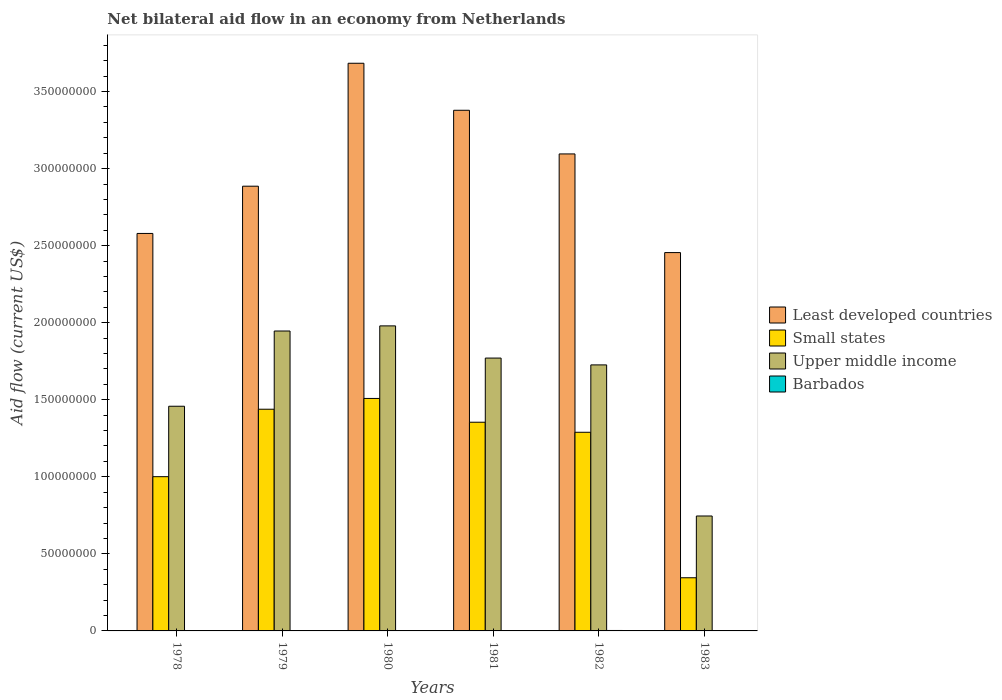How many different coloured bars are there?
Give a very brief answer. 4. How many groups of bars are there?
Offer a terse response. 6. How many bars are there on the 4th tick from the left?
Ensure brevity in your answer.  4. In how many cases, is the number of bars for a given year not equal to the number of legend labels?
Your answer should be very brief. 0. What is the net bilateral aid flow in Least developed countries in 1983?
Make the answer very short. 2.46e+08. Across all years, what is the maximum net bilateral aid flow in Upper middle income?
Offer a terse response. 1.98e+08. In which year was the net bilateral aid flow in Small states maximum?
Provide a succinct answer. 1980. In which year was the net bilateral aid flow in Small states minimum?
Your answer should be very brief. 1983. What is the total net bilateral aid flow in Least developed countries in the graph?
Provide a short and direct response. 1.81e+09. What is the difference between the net bilateral aid flow in Barbados in 1979 and that in 1980?
Provide a short and direct response. -7.00e+04. What is the difference between the net bilateral aid flow in Small states in 1982 and the net bilateral aid flow in Barbados in 1983?
Make the answer very short. 1.29e+08. What is the average net bilateral aid flow in Small states per year?
Make the answer very short. 1.16e+08. In the year 1981, what is the difference between the net bilateral aid flow in Small states and net bilateral aid flow in Least developed countries?
Give a very brief answer. -2.02e+08. What is the ratio of the net bilateral aid flow in Upper middle income in 1980 to that in 1983?
Provide a short and direct response. 2.65. Is the net bilateral aid flow in Least developed countries in 1980 less than that in 1981?
Offer a terse response. No. What is the difference between the highest and the second highest net bilateral aid flow in Upper middle income?
Your answer should be compact. 3.32e+06. What is the difference between the highest and the lowest net bilateral aid flow in Upper middle income?
Offer a terse response. 1.23e+08. In how many years, is the net bilateral aid flow in Upper middle income greater than the average net bilateral aid flow in Upper middle income taken over all years?
Offer a very short reply. 4. Is the sum of the net bilateral aid flow in Least developed countries in 1980 and 1983 greater than the maximum net bilateral aid flow in Barbados across all years?
Provide a short and direct response. Yes. What does the 2nd bar from the left in 1979 represents?
Provide a succinct answer. Small states. What does the 3rd bar from the right in 1978 represents?
Keep it short and to the point. Small states. Is it the case that in every year, the sum of the net bilateral aid flow in Least developed countries and net bilateral aid flow in Upper middle income is greater than the net bilateral aid flow in Barbados?
Make the answer very short. Yes. How many years are there in the graph?
Provide a short and direct response. 6. What is the difference between two consecutive major ticks on the Y-axis?
Your answer should be very brief. 5.00e+07. Are the values on the major ticks of Y-axis written in scientific E-notation?
Your answer should be compact. No. Does the graph contain any zero values?
Ensure brevity in your answer.  No. Where does the legend appear in the graph?
Offer a terse response. Center right. How many legend labels are there?
Ensure brevity in your answer.  4. What is the title of the graph?
Provide a short and direct response. Net bilateral aid flow in an economy from Netherlands. What is the label or title of the X-axis?
Your answer should be very brief. Years. What is the Aid flow (current US$) in Least developed countries in 1978?
Provide a short and direct response. 2.58e+08. What is the Aid flow (current US$) in Small states in 1978?
Provide a short and direct response. 1.00e+08. What is the Aid flow (current US$) of Upper middle income in 1978?
Make the answer very short. 1.46e+08. What is the Aid flow (current US$) in Barbados in 1978?
Provide a short and direct response. 7.00e+04. What is the Aid flow (current US$) in Least developed countries in 1979?
Your answer should be compact. 2.89e+08. What is the Aid flow (current US$) in Small states in 1979?
Give a very brief answer. 1.44e+08. What is the Aid flow (current US$) of Upper middle income in 1979?
Give a very brief answer. 1.95e+08. What is the Aid flow (current US$) in Barbados in 1979?
Keep it short and to the point. 4.00e+04. What is the Aid flow (current US$) in Least developed countries in 1980?
Make the answer very short. 3.68e+08. What is the Aid flow (current US$) in Small states in 1980?
Ensure brevity in your answer.  1.51e+08. What is the Aid flow (current US$) in Upper middle income in 1980?
Provide a succinct answer. 1.98e+08. What is the Aid flow (current US$) in Barbados in 1980?
Give a very brief answer. 1.10e+05. What is the Aid flow (current US$) in Least developed countries in 1981?
Offer a very short reply. 3.38e+08. What is the Aid flow (current US$) in Small states in 1981?
Your answer should be compact. 1.35e+08. What is the Aid flow (current US$) of Upper middle income in 1981?
Offer a very short reply. 1.77e+08. What is the Aid flow (current US$) in Barbados in 1981?
Provide a succinct answer. 2.00e+04. What is the Aid flow (current US$) in Least developed countries in 1982?
Your response must be concise. 3.10e+08. What is the Aid flow (current US$) in Small states in 1982?
Ensure brevity in your answer.  1.29e+08. What is the Aid flow (current US$) of Upper middle income in 1982?
Offer a very short reply. 1.73e+08. What is the Aid flow (current US$) of Barbados in 1982?
Your response must be concise. 2.90e+05. What is the Aid flow (current US$) in Least developed countries in 1983?
Give a very brief answer. 2.46e+08. What is the Aid flow (current US$) in Small states in 1983?
Give a very brief answer. 3.45e+07. What is the Aid flow (current US$) of Upper middle income in 1983?
Provide a succinct answer. 7.46e+07. What is the Aid flow (current US$) in Barbados in 1983?
Your response must be concise. 1.60e+05. Across all years, what is the maximum Aid flow (current US$) of Least developed countries?
Offer a terse response. 3.68e+08. Across all years, what is the maximum Aid flow (current US$) of Small states?
Make the answer very short. 1.51e+08. Across all years, what is the maximum Aid flow (current US$) of Upper middle income?
Ensure brevity in your answer.  1.98e+08. Across all years, what is the maximum Aid flow (current US$) in Barbados?
Your response must be concise. 2.90e+05. Across all years, what is the minimum Aid flow (current US$) of Least developed countries?
Your response must be concise. 2.46e+08. Across all years, what is the minimum Aid flow (current US$) of Small states?
Offer a very short reply. 3.45e+07. Across all years, what is the minimum Aid flow (current US$) in Upper middle income?
Your answer should be very brief. 7.46e+07. What is the total Aid flow (current US$) in Least developed countries in the graph?
Your response must be concise. 1.81e+09. What is the total Aid flow (current US$) of Small states in the graph?
Your response must be concise. 6.94e+08. What is the total Aid flow (current US$) in Upper middle income in the graph?
Ensure brevity in your answer.  9.63e+08. What is the total Aid flow (current US$) in Barbados in the graph?
Give a very brief answer. 6.90e+05. What is the difference between the Aid flow (current US$) of Least developed countries in 1978 and that in 1979?
Offer a very short reply. -3.07e+07. What is the difference between the Aid flow (current US$) in Small states in 1978 and that in 1979?
Keep it short and to the point. -4.38e+07. What is the difference between the Aid flow (current US$) in Upper middle income in 1978 and that in 1979?
Make the answer very short. -4.88e+07. What is the difference between the Aid flow (current US$) of Barbados in 1978 and that in 1979?
Give a very brief answer. 3.00e+04. What is the difference between the Aid flow (current US$) of Least developed countries in 1978 and that in 1980?
Offer a terse response. -1.10e+08. What is the difference between the Aid flow (current US$) in Small states in 1978 and that in 1980?
Your answer should be compact. -5.08e+07. What is the difference between the Aid flow (current US$) in Upper middle income in 1978 and that in 1980?
Your answer should be compact. -5.21e+07. What is the difference between the Aid flow (current US$) of Least developed countries in 1978 and that in 1981?
Your answer should be compact. -7.99e+07. What is the difference between the Aid flow (current US$) in Small states in 1978 and that in 1981?
Provide a succinct answer. -3.53e+07. What is the difference between the Aid flow (current US$) of Upper middle income in 1978 and that in 1981?
Provide a succinct answer. -3.12e+07. What is the difference between the Aid flow (current US$) of Barbados in 1978 and that in 1981?
Provide a short and direct response. 5.00e+04. What is the difference between the Aid flow (current US$) in Least developed countries in 1978 and that in 1982?
Offer a very short reply. -5.16e+07. What is the difference between the Aid flow (current US$) of Small states in 1978 and that in 1982?
Your answer should be compact. -2.88e+07. What is the difference between the Aid flow (current US$) in Upper middle income in 1978 and that in 1982?
Provide a succinct answer. -2.68e+07. What is the difference between the Aid flow (current US$) in Barbados in 1978 and that in 1982?
Your answer should be very brief. -2.20e+05. What is the difference between the Aid flow (current US$) in Least developed countries in 1978 and that in 1983?
Give a very brief answer. 1.24e+07. What is the difference between the Aid flow (current US$) of Small states in 1978 and that in 1983?
Provide a succinct answer. 6.56e+07. What is the difference between the Aid flow (current US$) of Upper middle income in 1978 and that in 1983?
Make the answer very short. 7.12e+07. What is the difference between the Aid flow (current US$) in Barbados in 1978 and that in 1983?
Keep it short and to the point. -9.00e+04. What is the difference between the Aid flow (current US$) in Least developed countries in 1979 and that in 1980?
Provide a short and direct response. -7.98e+07. What is the difference between the Aid flow (current US$) in Small states in 1979 and that in 1980?
Your answer should be compact. -6.99e+06. What is the difference between the Aid flow (current US$) in Upper middle income in 1979 and that in 1980?
Give a very brief answer. -3.32e+06. What is the difference between the Aid flow (current US$) of Least developed countries in 1979 and that in 1981?
Your answer should be very brief. -4.93e+07. What is the difference between the Aid flow (current US$) of Small states in 1979 and that in 1981?
Provide a succinct answer. 8.44e+06. What is the difference between the Aid flow (current US$) of Upper middle income in 1979 and that in 1981?
Provide a succinct answer. 1.76e+07. What is the difference between the Aid flow (current US$) in Least developed countries in 1979 and that in 1982?
Make the answer very short. -2.09e+07. What is the difference between the Aid flow (current US$) of Small states in 1979 and that in 1982?
Your answer should be very brief. 1.50e+07. What is the difference between the Aid flow (current US$) of Upper middle income in 1979 and that in 1982?
Your response must be concise. 2.20e+07. What is the difference between the Aid flow (current US$) in Barbados in 1979 and that in 1982?
Your answer should be very brief. -2.50e+05. What is the difference between the Aid flow (current US$) of Least developed countries in 1979 and that in 1983?
Your answer should be very brief. 4.31e+07. What is the difference between the Aid flow (current US$) in Small states in 1979 and that in 1983?
Ensure brevity in your answer.  1.09e+08. What is the difference between the Aid flow (current US$) in Upper middle income in 1979 and that in 1983?
Your answer should be compact. 1.20e+08. What is the difference between the Aid flow (current US$) of Barbados in 1979 and that in 1983?
Provide a short and direct response. -1.20e+05. What is the difference between the Aid flow (current US$) in Least developed countries in 1980 and that in 1981?
Your response must be concise. 3.05e+07. What is the difference between the Aid flow (current US$) in Small states in 1980 and that in 1981?
Give a very brief answer. 1.54e+07. What is the difference between the Aid flow (current US$) of Upper middle income in 1980 and that in 1981?
Your answer should be very brief. 2.09e+07. What is the difference between the Aid flow (current US$) of Least developed countries in 1980 and that in 1982?
Your response must be concise. 5.88e+07. What is the difference between the Aid flow (current US$) of Small states in 1980 and that in 1982?
Your response must be concise. 2.20e+07. What is the difference between the Aid flow (current US$) in Upper middle income in 1980 and that in 1982?
Ensure brevity in your answer.  2.53e+07. What is the difference between the Aid flow (current US$) in Barbados in 1980 and that in 1982?
Offer a terse response. -1.80e+05. What is the difference between the Aid flow (current US$) in Least developed countries in 1980 and that in 1983?
Provide a succinct answer. 1.23e+08. What is the difference between the Aid flow (current US$) in Small states in 1980 and that in 1983?
Ensure brevity in your answer.  1.16e+08. What is the difference between the Aid flow (current US$) of Upper middle income in 1980 and that in 1983?
Provide a short and direct response. 1.23e+08. What is the difference between the Aid flow (current US$) in Least developed countries in 1981 and that in 1982?
Your response must be concise. 2.83e+07. What is the difference between the Aid flow (current US$) of Small states in 1981 and that in 1982?
Offer a terse response. 6.52e+06. What is the difference between the Aid flow (current US$) of Upper middle income in 1981 and that in 1982?
Make the answer very short. 4.43e+06. What is the difference between the Aid flow (current US$) of Barbados in 1981 and that in 1982?
Give a very brief answer. -2.70e+05. What is the difference between the Aid flow (current US$) of Least developed countries in 1981 and that in 1983?
Provide a succinct answer. 9.24e+07. What is the difference between the Aid flow (current US$) in Small states in 1981 and that in 1983?
Provide a short and direct response. 1.01e+08. What is the difference between the Aid flow (current US$) of Upper middle income in 1981 and that in 1983?
Ensure brevity in your answer.  1.02e+08. What is the difference between the Aid flow (current US$) of Barbados in 1981 and that in 1983?
Ensure brevity in your answer.  -1.40e+05. What is the difference between the Aid flow (current US$) of Least developed countries in 1982 and that in 1983?
Give a very brief answer. 6.40e+07. What is the difference between the Aid flow (current US$) in Small states in 1982 and that in 1983?
Your answer should be compact. 9.44e+07. What is the difference between the Aid flow (current US$) in Upper middle income in 1982 and that in 1983?
Give a very brief answer. 9.80e+07. What is the difference between the Aid flow (current US$) of Least developed countries in 1978 and the Aid flow (current US$) of Small states in 1979?
Ensure brevity in your answer.  1.14e+08. What is the difference between the Aid flow (current US$) in Least developed countries in 1978 and the Aid flow (current US$) in Upper middle income in 1979?
Make the answer very short. 6.33e+07. What is the difference between the Aid flow (current US$) of Least developed countries in 1978 and the Aid flow (current US$) of Barbados in 1979?
Provide a succinct answer. 2.58e+08. What is the difference between the Aid flow (current US$) of Small states in 1978 and the Aid flow (current US$) of Upper middle income in 1979?
Offer a terse response. -9.45e+07. What is the difference between the Aid flow (current US$) of Small states in 1978 and the Aid flow (current US$) of Barbados in 1979?
Provide a succinct answer. 1.00e+08. What is the difference between the Aid flow (current US$) of Upper middle income in 1978 and the Aid flow (current US$) of Barbados in 1979?
Keep it short and to the point. 1.46e+08. What is the difference between the Aid flow (current US$) of Least developed countries in 1978 and the Aid flow (current US$) of Small states in 1980?
Your response must be concise. 1.07e+08. What is the difference between the Aid flow (current US$) of Least developed countries in 1978 and the Aid flow (current US$) of Upper middle income in 1980?
Provide a short and direct response. 6.00e+07. What is the difference between the Aid flow (current US$) in Least developed countries in 1978 and the Aid flow (current US$) in Barbados in 1980?
Your response must be concise. 2.58e+08. What is the difference between the Aid flow (current US$) of Small states in 1978 and the Aid flow (current US$) of Upper middle income in 1980?
Offer a terse response. -9.78e+07. What is the difference between the Aid flow (current US$) of Small states in 1978 and the Aid flow (current US$) of Barbados in 1980?
Keep it short and to the point. 1.00e+08. What is the difference between the Aid flow (current US$) in Upper middle income in 1978 and the Aid flow (current US$) in Barbados in 1980?
Your response must be concise. 1.46e+08. What is the difference between the Aid flow (current US$) of Least developed countries in 1978 and the Aid flow (current US$) of Small states in 1981?
Provide a short and direct response. 1.22e+08. What is the difference between the Aid flow (current US$) in Least developed countries in 1978 and the Aid flow (current US$) in Upper middle income in 1981?
Your response must be concise. 8.09e+07. What is the difference between the Aid flow (current US$) of Least developed countries in 1978 and the Aid flow (current US$) of Barbados in 1981?
Your response must be concise. 2.58e+08. What is the difference between the Aid flow (current US$) of Small states in 1978 and the Aid flow (current US$) of Upper middle income in 1981?
Provide a short and direct response. -7.70e+07. What is the difference between the Aid flow (current US$) in Small states in 1978 and the Aid flow (current US$) in Barbados in 1981?
Your response must be concise. 1.00e+08. What is the difference between the Aid flow (current US$) of Upper middle income in 1978 and the Aid flow (current US$) of Barbados in 1981?
Your answer should be very brief. 1.46e+08. What is the difference between the Aid flow (current US$) of Least developed countries in 1978 and the Aid flow (current US$) of Small states in 1982?
Give a very brief answer. 1.29e+08. What is the difference between the Aid flow (current US$) in Least developed countries in 1978 and the Aid flow (current US$) in Upper middle income in 1982?
Keep it short and to the point. 8.53e+07. What is the difference between the Aid flow (current US$) in Least developed countries in 1978 and the Aid flow (current US$) in Barbados in 1982?
Keep it short and to the point. 2.58e+08. What is the difference between the Aid flow (current US$) in Small states in 1978 and the Aid flow (current US$) in Upper middle income in 1982?
Give a very brief answer. -7.25e+07. What is the difference between the Aid flow (current US$) of Small states in 1978 and the Aid flow (current US$) of Barbados in 1982?
Ensure brevity in your answer.  9.98e+07. What is the difference between the Aid flow (current US$) in Upper middle income in 1978 and the Aid flow (current US$) in Barbados in 1982?
Make the answer very short. 1.46e+08. What is the difference between the Aid flow (current US$) in Least developed countries in 1978 and the Aid flow (current US$) in Small states in 1983?
Give a very brief answer. 2.23e+08. What is the difference between the Aid flow (current US$) in Least developed countries in 1978 and the Aid flow (current US$) in Upper middle income in 1983?
Provide a succinct answer. 1.83e+08. What is the difference between the Aid flow (current US$) in Least developed countries in 1978 and the Aid flow (current US$) in Barbados in 1983?
Provide a succinct answer. 2.58e+08. What is the difference between the Aid flow (current US$) of Small states in 1978 and the Aid flow (current US$) of Upper middle income in 1983?
Your answer should be compact. 2.55e+07. What is the difference between the Aid flow (current US$) in Small states in 1978 and the Aid flow (current US$) in Barbados in 1983?
Offer a terse response. 9.99e+07. What is the difference between the Aid flow (current US$) of Upper middle income in 1978 and the Aid flow (current US$) of Barbados in 1983?
Your response must be concise. 1.46e+08. What is the difference between the Aid flow (current US$) in Least developed countries in 1979 and the Aid flow (current US$) in Small states in 1980?
Your answer should be compact. 1.38e+08. What is the difference between the Aid flow (current US$) in Least developed countries in 1979 and the Aid flow (current US$) in Upper middle income in 1980?
Ensure brevity in your answer.  9.06e+07. What is the difference between the Aid flow (current US$) of Least developed countries in 1979 and the Aid flow (current US$) of Barbados in 1980?
Make the answer very short. 2.88e+08. What is the difference between the Aid flow (current US$) in Small states in 1979 and the Aid flow (current US$) in Upper middle income in 1980?
Give a very brief answer. -5.41e+07. What is the difference between the Aid flow (current US$) of Small states in 1979 and the Aid flow (current US$) of Barbados in 1980?
Your answer should be very brief. 1.44e+08. What is the difference between the Aid flow (current US$) of Upper middle income in 1979 and the Aid flow (current US$) of Barbados in 1980?
Your answer should be very brief. 1.95e+08. What is the difference between the Aid flow (current US$) of Least developed countries in 1979 and the Aid flow (current US$) of Small states in 1981?
Your answer should be very brief. 1.53e+08. What is the difference between the Aid flow (current US$) in Least developed countries in 1979 and the Aid flow (current US$) in Upper middle income in 1981?
Ensure brevity in your answer.  1.12e+08. What is the difference between the Aid flow (current US$) in Least developed countries in 1979 and the Aid flow (current US$) in Barbados in 1981?
Make the answer very short. 2.89e+08. What is the difference between the Aid flow (current US$) of Small states in 1979 and the Aid flow (current US$) of Upper middle income in 1981?
Make the answer very short. -3.32e+07. What is the difference between the Aid flow (current US$) of Small states in 1979 and the Aid flow (current US$) of Barbados in 1981?
Provide a succinct answer. 1.44e+08. What is the difference between the Aid flow (current US$) in Upper middle income in 1979 and the Aid flow (current US$) in Barbados in 1981?
Offer a very short reply. 1.95e+08. What is the difference between the Aid flow (current US$) in Least developed countries in 1979 and the Aid flow (current US$) in Small states in 1982?
Give a very brief answer. 1.60e+08. What is the difference between the Aid flow (current US$) of Least developed countries in 1979 and the Aid flow (current US$) of Upper middle income in 1982?
Keep it short and to the point. 1.16e+08. What is the difference between the Aid flow (current US$) in Least developed countries in 1979 and the Aid flow (current US$) in Barbados in 1982?
Your response must be concise. 2.88e+08. What is the difference between the Aid flow (current US$) in Small states in 1979 and the Aid flow (current US$) in Upper middle income in 1982?
Provide a succinct answer. -2.88e+07. What is the difference between the Aid flow (current US$) in Small states in 1979 and the Aid flow (current US$) in Barbados in 1982?
Make the answer very short. 1.44e+08. What is the difference between the Aid flow (current US$) in Upper middle income in 1979 and the Aid flow (current US$) in Barbados in 1982?
Provide a succinct answer. 1.94e+08. What is the difference between the Aid flow (current US$) in Least developed countries in 1979 and the Aid flow (current US$) in Small states in 1983?
Give a very brief answer. 2.54e+08. What is the difference between the Aid flow (current US$) in Least developed countries in 1979 and the Aid flow (current US$) in Upper middle income in 1983?
Offer a terse response. 2.14e+08. What is the difference between the Aid flow (current US$) in Least developed countries in 1979 and the Aid flow (current US$) in Barbados in 1983?
Provide a short and direct response. 2.88e+08. What is the difference between the Aid flow (current US$) in Small states in 1979 and the Aid flow (current US$) in Upper middle income in 1983?
Give a very brief answer. 6.93e+07. What is the difference between the Aid flow (current US$) of Small states in 1979 and the Aid flow (current US$) of Barbados in 1983?
Provide a short and direct response. 1.44e+08. What is the difference between the Aid flow (current US$) of Upper middle income in 1979 and the Aid flow (current US$) of Barbados in 1983?
Give a very brief answer. 1.94e+08. What is the difference between the Aid flow (current US$) in Least developed countries in 1980 and the Aid flow (current US$) in Small states in 1981?
Your answer should be compact. 2.33e+08. What is the difference between the Aid flow (current US$) of Least developed countries in 1980 and the Aid flow (current US$) of Upper middle income in 1981?
Offer a very short reply. 1.91e+08. What is the difference between the Aid flow (current US$) of Least developed countries in 1980 and the Aid flow (current US$) of Barbados in 1981?
Keep it short and to the point. 3.68e+08. What is the difference between the Aid flow (current US$) of Small states in 1980 and the Aid flow (current US$) of Upper middle income in 1981?
Make the answer very short. -2.62e+07. What is the difference between the Aid flow (current US$) of Small states in 1980 and the Aid flow (current US$) of Barbados in 1981?
Your response must be concise. 1.51e+08. What is the difference between the Aid flow (current US$) of Upper middle income in 1980 and the Aid flow (current US$) of Barbados in 1981?
Ensure brevity in your answer.  1.98e+08. What is the difference between the Aid flow (current US$) of Least developed countries in 1980 and the Aid flow (current US$) of Small states in 1982?
Give a very brief answer. 2.39e+08. What is the difference between the Aid flow (current US$) of Least developed countries in 1980 and the Aid flow (current US$) of Upper middle income in 1982?
Your response must be concise. 1.96e+08. What is the difference between the Aid flow (current US$) of Least developed countries in 1980 and the Aid flow (current US$) of Barbados in 1982?
Provide a succinct answer. 3.68e+08. What is the difference between the Aid flow (current US$) of Small states in 1980 and the Aid flow (current US$) of Upper middle income in 1982?
Keep it short and to the point. -2.18e+07. What is the difference between the Aid flow (current US$) in Small states in 1980 and the Aid flow (current US$) in Barbados in 1982?
Your response must be concise. 1.51e+08. What is the difference between the Aid flow (current US$) of Upper middle income in 1980 and the Aid flow (current US$) of Barbados in 1982?
Provide a short and direct response. 1.98e+08. What is the difference between the Aid flow (current US$) in Least developed countries in 1980 and the Aid flow (current US$) in Small states in 1983?
Make the answer very short. 3.34e+08. What is the difference between the Aid flow (current US$) of Least developed countries in 1980 and the Aid flow (current US$) of Upper middle income in 1983?
Provide a short and direct response. 2.94e+08. What is the difference between the Aid flow (current US$) of Least developed countries in 1980 and the Aid flow (current US$) of Barbados in 1983?
Offer a terse response. 3.68e+08. What is the difference between the Aid flow (current US$) in Small states in 1980 and the Aid flow (current US$) in Upper middle income in 1983?
Keep it short and to the point. 7.63e+07. What is the difference between the Aid flow (current US$) of Small states in 1980 and the Aid flow (current US$) of Barbados in 1983?
Ensure brevity in your answer.  1.51e+08. What is the difference between the Aid flow (current US$) of Upper middle income in 1980 and the Aid flow (current US$) of Barbados in 1983?
Keep it short and to the point. 1.98e+08. What is the difference between the Aid flow (current US$) in Least developed countries in 1981 and the Aid flow (current US$) in Small states in 1982?
Give a very brief answer. 2.09e+08. What is the difference between the Aid flow (current US$) of Least developed countries in 1981 and the Aid flow (current US$) of Upper middle income in 1982?
Provide a short and direct response. 1.65e+08. What is the difference between the Aid flow (current US$) of Least developed countries in 1981 and the Aid flow (current US$) of Barbados in 1982?
Offer a terse response. 3.38e+08. What is the difference between the Aid flow (current US$) in Small states in 1981 and the Aid flow (current US$) in Upper middle income in 1982?
Your response must be concise. -3.72e+07. What is the difference between the Aid flow (current US$) in Small states in 1981 and the Aid flow (current US$) in Barbados in 1982?
Offer a very short reply. 1.35e+08. What is the difference between the Aid flow (current US$) of Upper middle income in 1981 and the Aid flow (current US$) of Barbados in 1982?
Make the answer very short. 1.77e+08. What is the difference between the Aid flow (current US$) in Least developed countries in 1981 and the Aid flow (current US$) in Small states in 1983?
Provide a succinct answer. 3.03e+08. What is the difference between the Aid flow (current US$) of Least developed countries in 1981 and the Aid flow (current US$) of Upper middle income in 1983?
Your answer should be very brief. 2.63e+08. What is the difference between the Aid flow (current US$) of Least developed countries in 1981 and the Aid flow (current US$) of Barbados in 1983?
Ensure brevity in your answer.  3.38e+08. What is the difference between the Aid flow (current US$) of Small states in 1981 and the Aid flow (current US$) of Upper middle income in 1983?
Your answer should be very brief. 6.08e+07. What is the difference between the Aid flow (current US$) of Small states in 1981 and the Aid flow (current US$) of Barbados in 1983?
Provide a short and direct response. 1.35e+08. What is the difference between the Aid flow (current US$) of Upper middle income in 1981 and the Aid flow (current US$) of Barbados in 1983?
Provide a succinct answer. 1.77e+08. What is the difference between the Aid flow (current US$) in Least developed countries in 1982 and the Aid flow (current US$) in Small states in 1983?
Your response must be concise. 2.75e+08. What is the difference between the Aid flow (current US$) of Least developed countries in 1982 and the Aid flow (current US$) of Upper middle income in 1983?
Your response must be concise. 2.35e+08. What is the difference between the Aid flow (current US$) in Least developed countries in 1982 and the Aid flow (current US$) in Barbados in 1983?
Ensure brevity in your answer.  3.09e+08. What is the difference between the Aid flow (current US$) in Small states in 1982 and the Aid flow (current US$) in Upper middle income in 1983?
Your answer should be compact. 5.43e+07. What is the difference between the Aid flow (current US$) of Small states in 1982 and the Aid flow (current US$) of Barbados in 1983?
Make the answer very short. 1.29e+08. What is the difference between the Aid flow (current US$) in Upper middle income in 1982 and the Aid flow (current US$) in Barbados in 1983?
Provide a short and direct response. 1.72e+08. What is the average Aid flow (current US$) in Least developed countries per year?
Your answer should be very brief. 3.01e+08. What is the average Aid flow (current US$) in Small states per year?
Your response must be concise. 1.16e+08. What is the average Aid flow (current US$) in Upper middle income per year?
Provide a succinct answer. 1.60e+08. What is the average Aid flow (current US$) of Barbados per year?
Provide a succinct answer. 1.15e+05. In the year 1978, what is the difference between the Aid flow (current US$) in Least developed countries and Aid flow (current US$) in Small states?
Provide a short and direct response. 1.58e+08. In the year 1978, what is the difference between the Aid flow (current US$) of Least developed countries and Aid flow (current US$) of Upper middle income?
Offer a very short reply. 1.12e+08. In the year 1978, what is the difference between the Aid flow (current US$) of Least developed countries and Aid flow (current US$) of Barbados?
Offer a very short reply. 2.58e+08. In the year 1978, what is the difference between the Aid flow (current US$) in Small states and Aid flow (current US$) in Upper middle income?
Give a very brief answer. -4.57e+07. In the year 1978, what is the difference between the Aid flow (current US$) in Small states and Aid flow (current US$) in Barbados?
Provide a short and direct response. 1.00e+08. In the year 1978, what is the difference between the Aid flow (current US$) of Upper middle income and Aid flow (current US$) of Barbados?
Offer a terse response. 1.46e+08. In the year 1979, what is the difference between the Aid flow (current US$) of Least developed countries and Aid flow (current US$) of Small states?
Your answer should be very brief. 1.45e+08. In the year 1979, what is the difference between the Aid flow (current US$) in Least developed countries and Aid flow (current US$) in Upper middle income?
Offer a terse response. 9.40e+07. In the year 1979, what is the difference between the Aid flow (current US$) in Least developed countries and Aid flow (current US$) in Barbados?
Provide a succinct answer. 2.89e+08. In the year 1979, what is the difference between the Aid flow (current US$) of Small states and Aid flow (current US$) of Upper middle income?
Your answer should be compact. -5.08e+07. In the year 1979, what is the difference between the Aid flow (current US$) of Small states and Aid flow (current US$) of Barbados?
Provide a succinct answer. 1.44e+08. In the year 1979, what is the difference between the Aid flow (current US$) in Upper middle income and Aid flow (current US$) in Barbados?
Your answer should be compact. 1.95e+08. In the year 1980, what is the difference between the Aid flow (current US$) in Least developed countries and Aid flow (current US$) in Small states?
Your answer should be very brief. 2.18e+08. In the year 1980, what is the difference between the Aid flow (current US$) in Least developed countries and Aid flow (current US$) in Upper middle income?
Keep it short and to the point. 1.70e+08. In the year 1980, what is the difference between the Aid flow (current US$) in Least developed countries and Aid flow (current US$) in Barbados?
Ensure brevity in your answer.  3.68e+08. In the year 1980, what is the difference between the Aid flow (current US$) in Small states and Aid flow (current US$) in Upper middle income?
Provide a succinct answer. -4.71e+07. In the year 1980, what is the difference between the Aid flow (current US$) of Small states and Aid flow (current US$) of Barbados?
Offer a terse response. 1.51e+08. In the year 1980, what is the difference between the Aid flow (current US$) in Upper middle income and Aid flow (current US$) in Barbados?
Offer a very short reply. 1.98e+08. In the year 1981, what is the difference between the Aid flow (current US$) of Least developed countries and Aid flow (current US$) of Small states?
Provide a succinct answer. 2.02e+08. In the year 1981, what is the difference between the Aid flow (current US$) of Least developed countries and Aid flow (current US$) of Upper middle income?
Your answer should be compact. 1.61e+08. In the year 1981, what is the difference between the Aid flow (current US$) in Least developed countries and Aid flow (current US$) in Barbados?
Give a very brief answer. 3.38e+08. In the year 1981, what is the difference between the Aid flow (current US$) in Small states and Aid flow (current US$) in Upper middle income?
Keep it short and to the point. -4.16e+07. In the year 1981, what is the difference between the Aid flow (current US$) of Small states and Aid flow (current US$) of Barbados?
Give a very brief answer. 1.35e+08. In the year 1981, what is the difference between the Aid flow (current US$) of Upper middle income and Aid flow (current US$) of Barbados?
Your response must be concise. 1.77e+08. In the year 1982, what is the difference between the Aid flow (current US$) of Least developed countries and Aid flow (current US$) of Small states?
Offer a terse response. 1.81e+08. In the year 1982, what is the difference between the Aid flow (current US$) in Least developed countries and Aid flow (current US$) in Upper middle income?
Keep it short and to the point. 1.37e+08. In the year 1982, what is the difference between the Aid flow (current US$) of Least developed countries and Aid flow (current US$) of Barbados?
Provide a succinct answer. 3.09e+08. In the year 1982, what is the difference between the Aid flow (current US$) in Small states and Aid flow (current US$) in Upper middle income?
Offer a terse response. -4.37e+07. In the year 1982, what is the difference between the Aid flow (current US$) of Small states and Aid flow (current US$) of Barbados?
Provide a succinct answer. 1.29e+08. In the year 1982, what is the difference between the Aid flow (current US$) in Upper middle income and Aid flow (current US$) in Barbados?
Your answer should be compact. 1.72e+08. In the year 1983, what is the difference between the Aid flow (current US$) in Least developed countries and Aid flow (current US$) in Small states?
Ensure brevity in your answer.  2.11e+08. In the year 1983, what is the difference between the Aid flow (current US$) in Least developed countries and Aid flow (current US$) in Upper middle income?
Give a very brief answer. 1.71e+08. In the year 1983, what is the difference between the Aid flow (current US$) of Least developed countries and Aid flow (current US$) of Barbados?
Offer a very short reply. 2.45e+08. In the year 1983, what is the difference between the Aid flow (current US$) in Small states and Aid flow (current US$) in Upper middle income?
Give a very brief answer. -4.01e+07. In the year 1983, what is the difference between the Aid flow (current US$) in Small states and Aid flow (current US$) in Barbados?
Offer a very short reply. 3.43e+07. In the year 1983, what is the difference between the Aid flow (current US$) of Upper middle income and Aid flow (current US$) of Barbados?
Give a very brief answer. 7.44e+07. What is the ratio of the Aid flow (current US$) of Least developed countries in 1978 to that in 1979?
Offer a terse response. 0.89. What is the ratio of the Aid flow (current US$) of Small states in 1978 to that in 1979?
Offer a terse response. 0.7. What is the ratio of the Aid flow (current US$) in Upper middle income in 1978 to that in 1979?
Give a very brief answer. 0.75. What is the ratio of the Aid flow (current US$) in Barbados in 1978 to that in 1979?
Offer a terse response. 1.75. What is the ratio of the Aid flow (current US$) in Least developed countries in 1978 to that in 1980?
Ensure brevity in your answer.  0.7. What is the ratio of the Aid flow (current US$) in Small states in 1978 to that in 1980?
Ensure brevity in your answer.  0.66. What is the ratio of the Aid flow (current US$) of Upper middle income in 1978 to that in 1980?
Offer a very short reply. 0.74. What is the ratio of the Aid flow (current US$) in Barbados in 1978 to that in 1980?
Give a very brief answer. 0.64. What is the ratio of the Aid flow (current US$) in Least developed countries in 1978 to that in 1981?
Your answer should be compact. 0.76. What is the ratio of the Aid flow (current US$) of Small states in 1978 to that in 1981?
Your answer should be compact. 0.74. What is the ratio of the Aid flow (current US$) of Upper middle income in 1978 to that in 1981?
Give a very brief answer. 0.82. What is the ratio of the Aid flow (current US$) in Barbados in 1978 to that in 1981?
Your response must be concise. 3.5. What is the ratio of the Aid flow (current US$) of Least developed countries in 1978 to that in 1982?
Offer a terse response. 0.83. What is the ratio of the Aid flow (current US$) of Small states in 1978 to that in 1982?
Your response must be concise. 0.78. What is the ratio of the Aid flow (current US$) in Upper middle income in 1978 to that in 1982?
Your answer should be very brief. 0.84. What is the ratio of the Aid flow (current US$) of Barbados in 1978 to that in 1982?
Make the answer very short. 0.24. What is the ratio of the Aid flow (current US$) of Least developed countries in 1978 to that in 1983?
Your answer should be compact. 1.05. What is the ratio of the Aid flow (current US$) in Small states in 1978 to that in 1983?
Ensure brevity in your answer.  2.9. What is the ratio of the Aid flow (current US$) of Upper middle income in 1978 to that in 1983?
Offer a very short reply. 1.95. What is the ratio of the Aid flow (current US$) of Barbados in 1978 to that in 1983?
Provide a short and direct response. 0.44. What is the ratio of the Aid flow (current US$) of Least developed countries in 1979 to that in 1980?
Keep it short and to the point. 0.78. What is the ratio of the Aid flow (current US$) in Small states in 1979 to that in 1980?
Your response must be concise. 0.95. What is the ratio of the Aid flow (current US$) of Upper middle income in 1979 to that in 1980?
Your response must be concise. 0.98. What is the ratio of the Aid flow (current US$) in Barbados in 1979 to that in 1980?
Your response must be concise. 0.36. What is the ratio of the Aid flow (current US$) of Least developed countries in 1979 to that in 1981?
Provide a short and direct response. 0.85. What is the ratio of the Aid flow (current US$) in Small states in 1979 to that in 1981?
Your answer should be very brief. 1.06. What is the ratio of the Aid flow (current US$) in Upper middle income in 1979 to that in 1981?
Provide a succinct answer. 1.1. What is the ratio of the Aid flow (current US$) of Least developed countries in 1979 to that in 1982?
Make the answer very short. 0.93. What is the ratio of the Aid flow (current US$) in Small states in 1979 to that in 1982?
Keep it short and to the point. 1.12. What is the ratio of the Aid flow (current US$) of Upper middle income in 1979 to that in 1982?
Provide a succinct answer. 1.13. What is the ratio of the Aid flow (current US$) in Barbados in 1979 to that in 1982?
Keep it short and to the point. 0.14. What is the ratio of the Aid flow (current US$) in Least developed countries in 1979 to that in 1983?
Your answer should be compact. 1.18. What is the ratio of the Aid flow (current US$) in Small states in 1979 to that in 1983?
Make the answer very short. 4.17. What is the ratio of the Aid flow (current US$) of Upper middle income in 1979 to that in 1983?
Make the answer very short. 2.61. What is the ratio of the Aid flow (current US$) of Least developed countries in 1980 to that in 1981?
Your response must be concise. 1.09. What is the ratio of the Aid flow (current US$) of Small states in 1980 to that in 1981?
Offer a very short reply. 1.11. What is the ratio of the Aid flow (current US$) in Upper middle income in 1980 to that in 1981?
Ensure brevity in your answer.  1.12. What is the ratio of the Aid flow (current US$) in Barbados in 1980 to that in 1981?
Keep it short and to the point. 5.5. What is the ratio of the Aid flow (current US$) of Least developed countries in 1980 to that in 1982?
Keep it short and to the point. 1.19. What is the ratio of the Aid flow (current US$) of Small states in 1980 to that in 1982?
Make the answer very short. 1.17. What is the ratio of the Aid flow (current US$) in Upper middle income in 1980 to that in 1982?
Keep it short and to the point. 1.15. What is the ratio of the Aid flow (current US$) of Barbados in 1980 to that in 1982?
Provide a short and direct response. 0.38. What is the ratio of the Aid flow (current US$) of Least developed countries in 1980 to that in 1983?
Your answer should be compact. 1.5. What is the ratio of the Aid flow (current US$) of Small states in 1980 to that in 1983?
Make the answer very short. 4.37. What is the ratio of the Aid flow (current US$) in Upper middle income in 1980 to that in 1983?
Your answer should be compact. 2.65. What is the ratio of the Aid flow (current US$) of Barbados in 1980 to that in 1983?
Offer a very short reply. 0.69. What is the ratio of the Aid flow (current US$) of Least developed countries in 1981 to that in 1982?
Your response must be concise. 1.09. What is the ratio of the Aid flow (current US$) in Small states in 1981 to that in 1982?
Offer a very short reply. 1.05. What is the ratio of the Aid flow (current US$) of Upper middle income in 1981 to that in 1982?
Provide a succinct answer. 1.03. What is the ratio of the Aid flow (current US$) in Barbados in 1981 to that in 1982?
Offer a very short reply. 0.07. What is the ratio of the Aid flow (current US$) in Least developed countries in 1981 to that in 1983?
Give a very brief answer. 1.38. What is the ratio of the Aid flow (current US$) in Small states in 1981 to that in 1983?
Ensure brevity in your answer.  3.93. What is the ratio of the Aid flow (current US$) of Upper middle income in 1981 to that in 1983?
Provide a short and direct response. 2.37. What is the ratio of the Aid flow (current US$) in Least developed countries in 1982 to that in 1983?
Keep it short and to the point. 1.26. What is the ratio of the Aid flow (current US$) in Small states in 1982 to that in 1983?
Make the answer very short. 3.74. What is the ratio of the Aid flow (current US$) in Upper middle income in 1982 to that in 1983?
Make the answer very short. 2.31. What is the ratio of the Aid flow (current US$) in Barbados in 1982 to that in 1983?
Keep it short and to the point. 1.81. What is the difference between the highest and the second highest Aid flow (current US$) of Least developed countries?
Ensure brevity in your answer.  3.05e+07. What is the difference between the highest and the second highest Aid flow (current US$) of Small states?
Offer a terse response. 6.99e+06. What is the difference between the highest and the second highest Aid flow (current US$) of Upper middle income?
Your response must be concise. 3.32e+06. What is the difference between the highest and the lowest Aid flow (current US$) of Least developed countries?
Keep it short and to the point. 1.23e+08. What is the difference between the highest and the lowest Aid flow (current US$) in Small states?
Offer a very short reply. 1.16e+08. What is the difference between the highest and the lowest Aid flow (current US$) in Upper middle income?
Give a very brief answer. 1.23e+08. What is the difference between the highest and the lowest Aid flow (current US$) of Barbados?
Keep it short and to the point. 2.70e+05. 